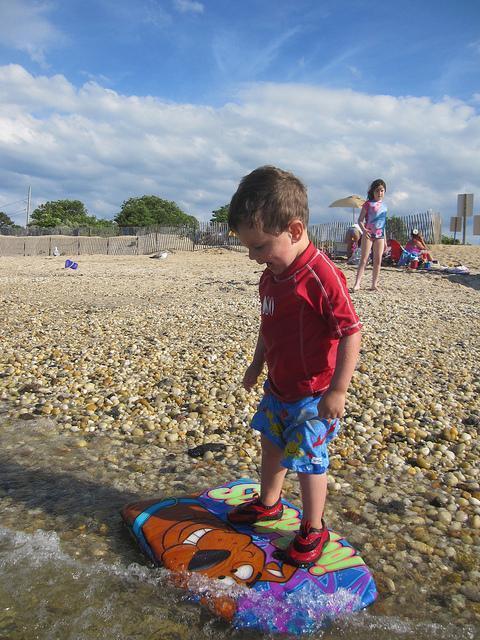How many people are there?
Give a very brief answer. 2. How many surfboards are in the picture?
Give a very brief answer. 1. 